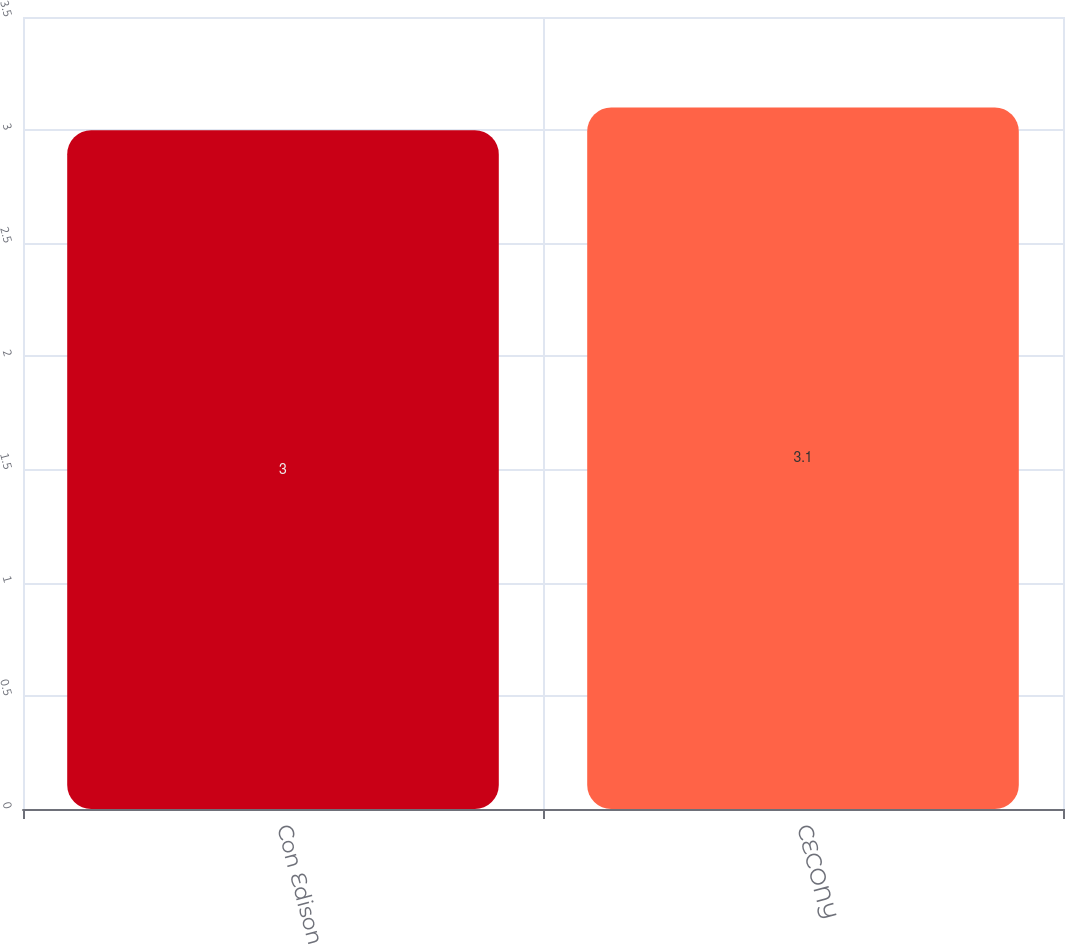<chart> <loc_0><loc_0><loc_500><loc_500><bar_chart><fcel>Con Edison<fcel>CECONY<nl><fcel>3<fcel>3.1<nl></chart> 